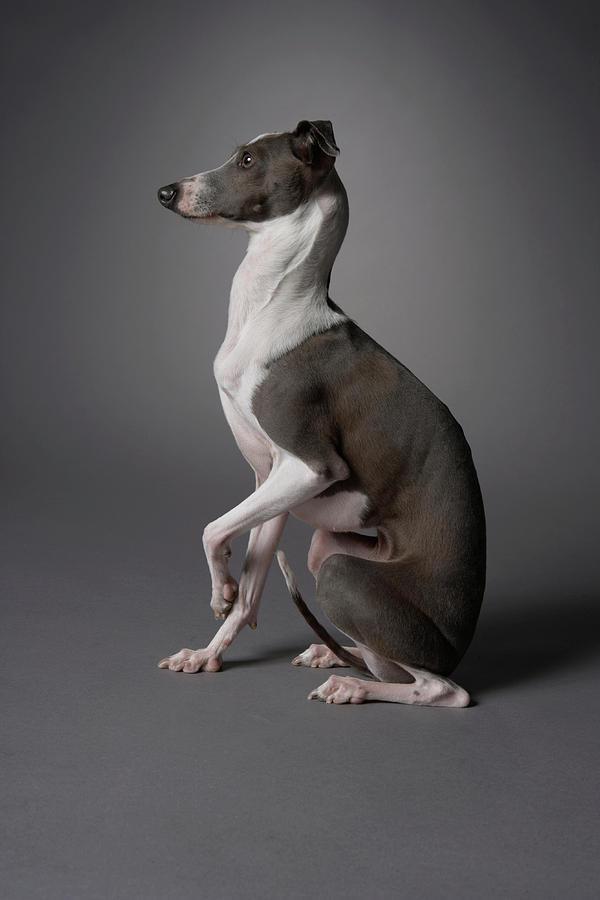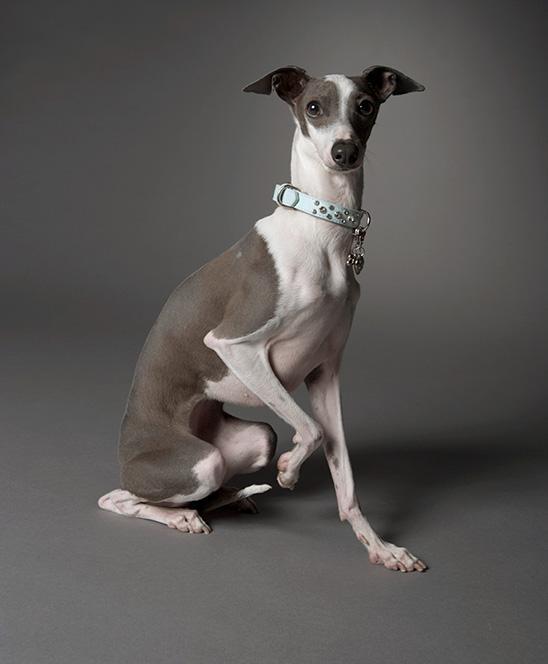The first image is the image on the left, the second image is the image on the right. Analyze the images presented: Is the assertion "Exactly one of the dogs is lying down." valid? Answer yes or no. No. The first image is the image on the left, the second image is the image on the right. Considering the images on both sides, is "An image shows a two-color dog sitting upright with its eyes on the camera." valid? Answer yes or no. Yes. 